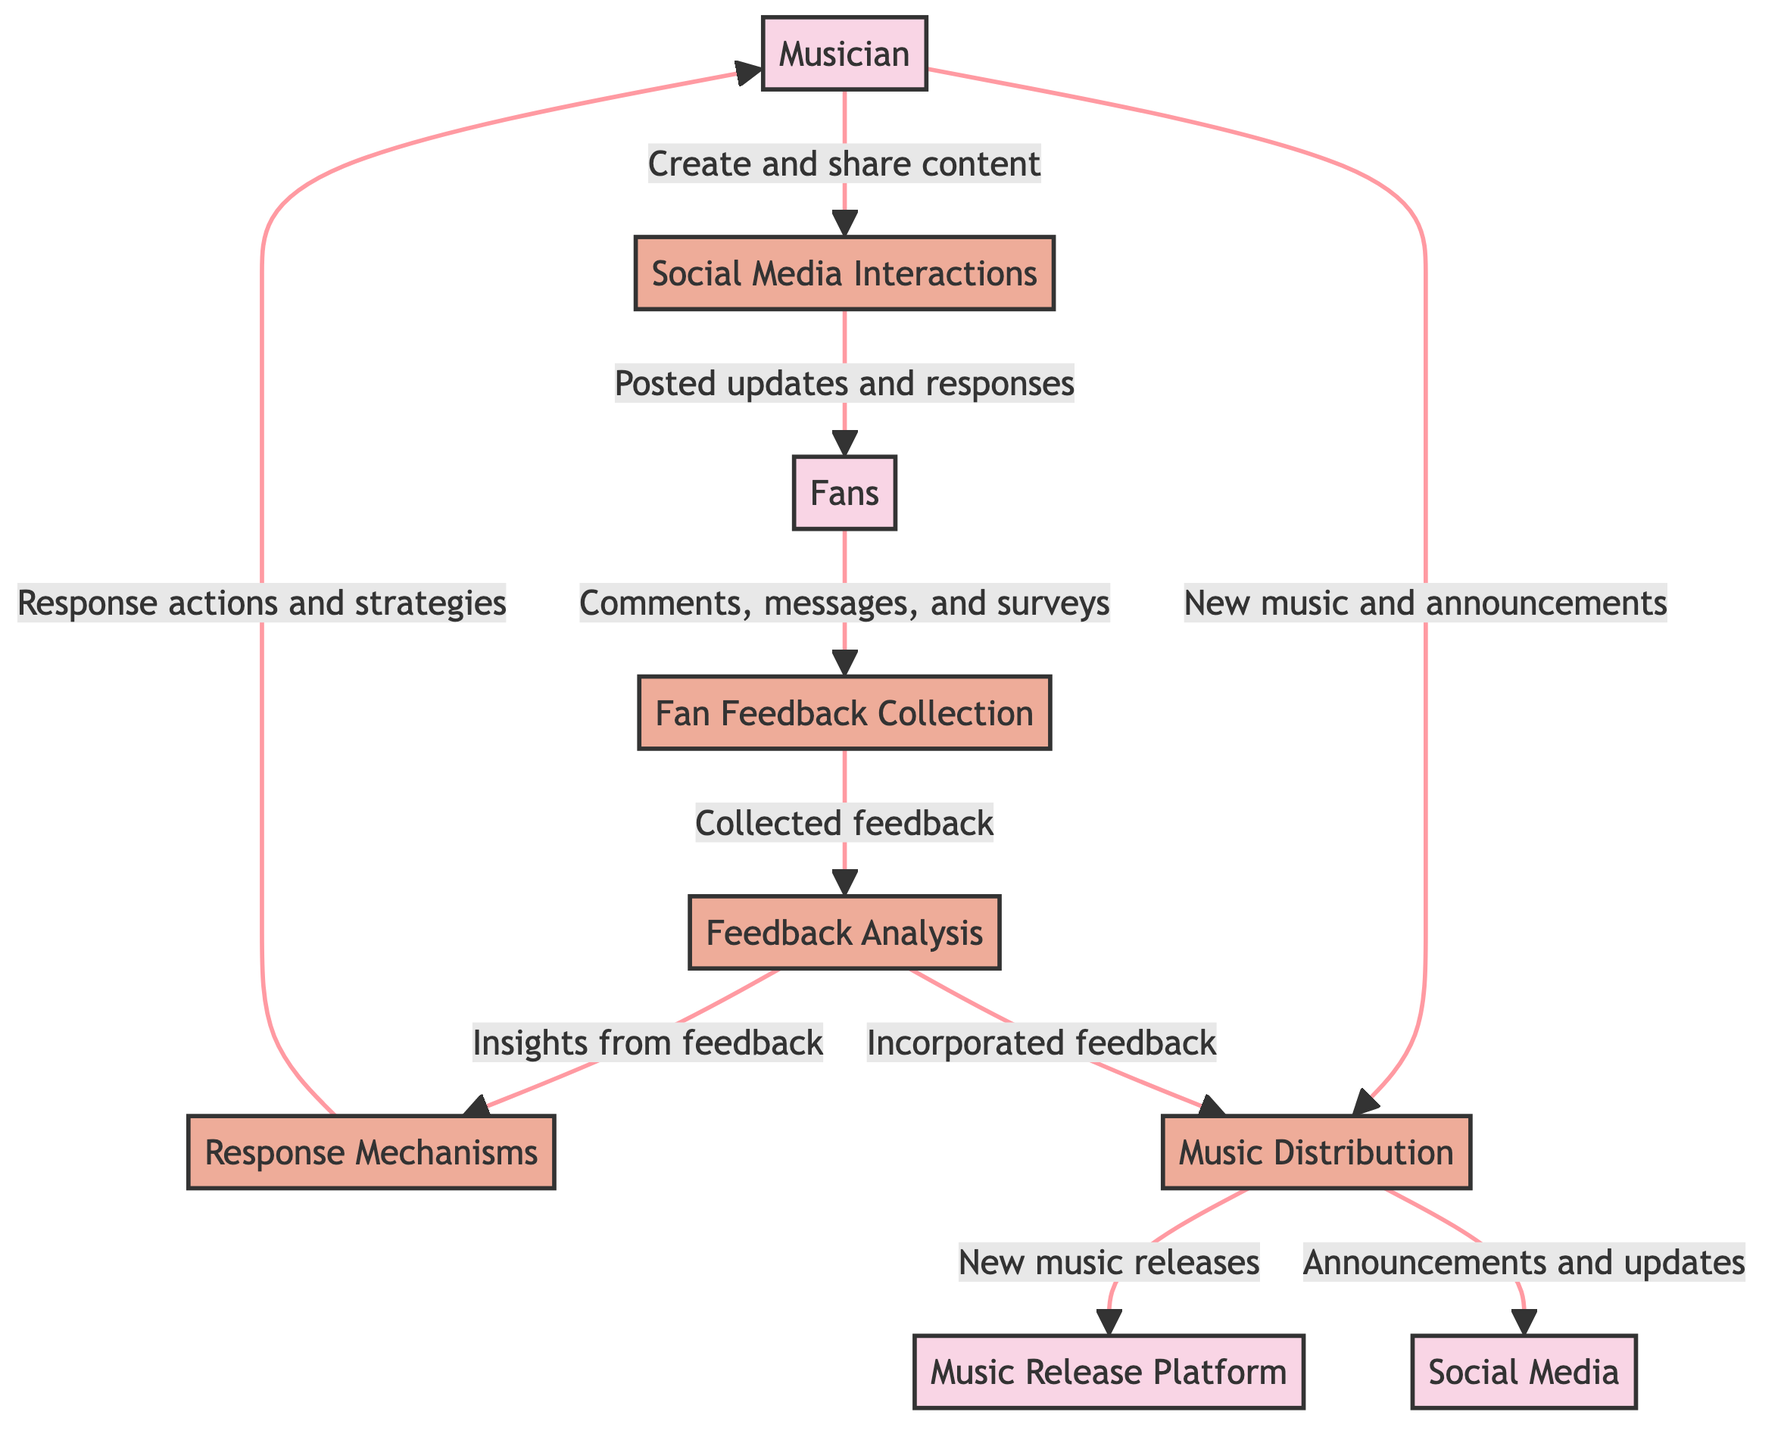What are the inputs for the "Social Media Interactions" process? The "Social Media Interactions" process receives input from the "Musician" entity, as the musician creates and shares content that leads to interactions.
Answer: Musician How many external entities are present in the diagram? The diagram includes four external entities: Musician, Music Release Platform, Social Media, and Fans. Counting these gives a total of four entities.
Answer: 4 What is the output of the "Feedback Analysis" process? The "Feedback Analysis" process outputs to the "Response Mechanisms" process. This means that the insights gained from analyzing feedback will be used to form responses.
Answer: Response Mechanisms What process comes after "Fan Feedback Collection" in the flow? The process that follows "Fan Feedback Collection" is "Feedback Analysis." This indicates that collected feedback is then analyzed to derive insights.
Answer: Feedback Analysis Which entities are directly involved in the "Music Distribution" process? The "Music Distribution" process involves two contributors: the "Musician" who provides new music and announcements, and the "Feedback Analysis" process that incorporates insights from feedback.
Answer: Musician, Feedback Analysis What mechanism allows the musician to respond to fan feedback? The "Response Mechanisms" process is responsible for enabling the musician to reply to fan feedback. This includes actions like thank-you messages or Q&A sessions based on the feedback received.
Answer: Response Mechanisms What type of data is collected from fans? Fans provide comments, messages, and responses to surveys, which are used in the "Fan Feedback Collection" process. This constitutes the data collected from fans regarding their engagement.
Answer: Comments, messages, surveys How does feedback analysis influence music distribution? Feedback analysis directly influences music distribution by incorporating insights derived from fan feedback into the process of distributing new music and announcements. This means that fan preferences can shape the content released.
Answer: Incorporated feedback What does the "Music Release Platform" receive from the "Music Distribution" process? The "Music Release Platform" receives new music releases from the "Music Distribution" process. This is the designated output of the music distribution action, where new tracks are delivered to the platform.
Answer: New music releases 